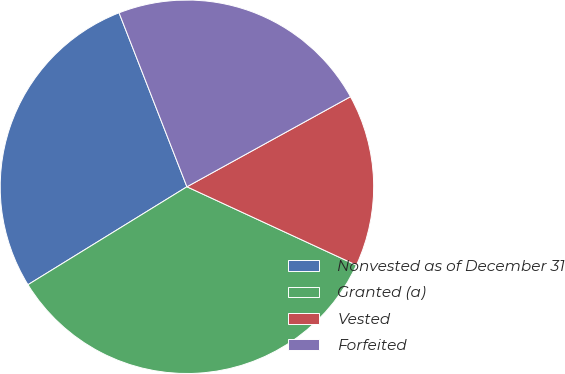<chart> <loc_0><loc_0><loc_500><loc_500><pie_chart><fcel>Nonvested as of December 31<fcel>Granted (a)<fcel>Vested<fcel>Forfeited<nl><fcel>27.87%<fcel>34.32%<fcel>14.91%<fcel>22.91%<nl></chart> 